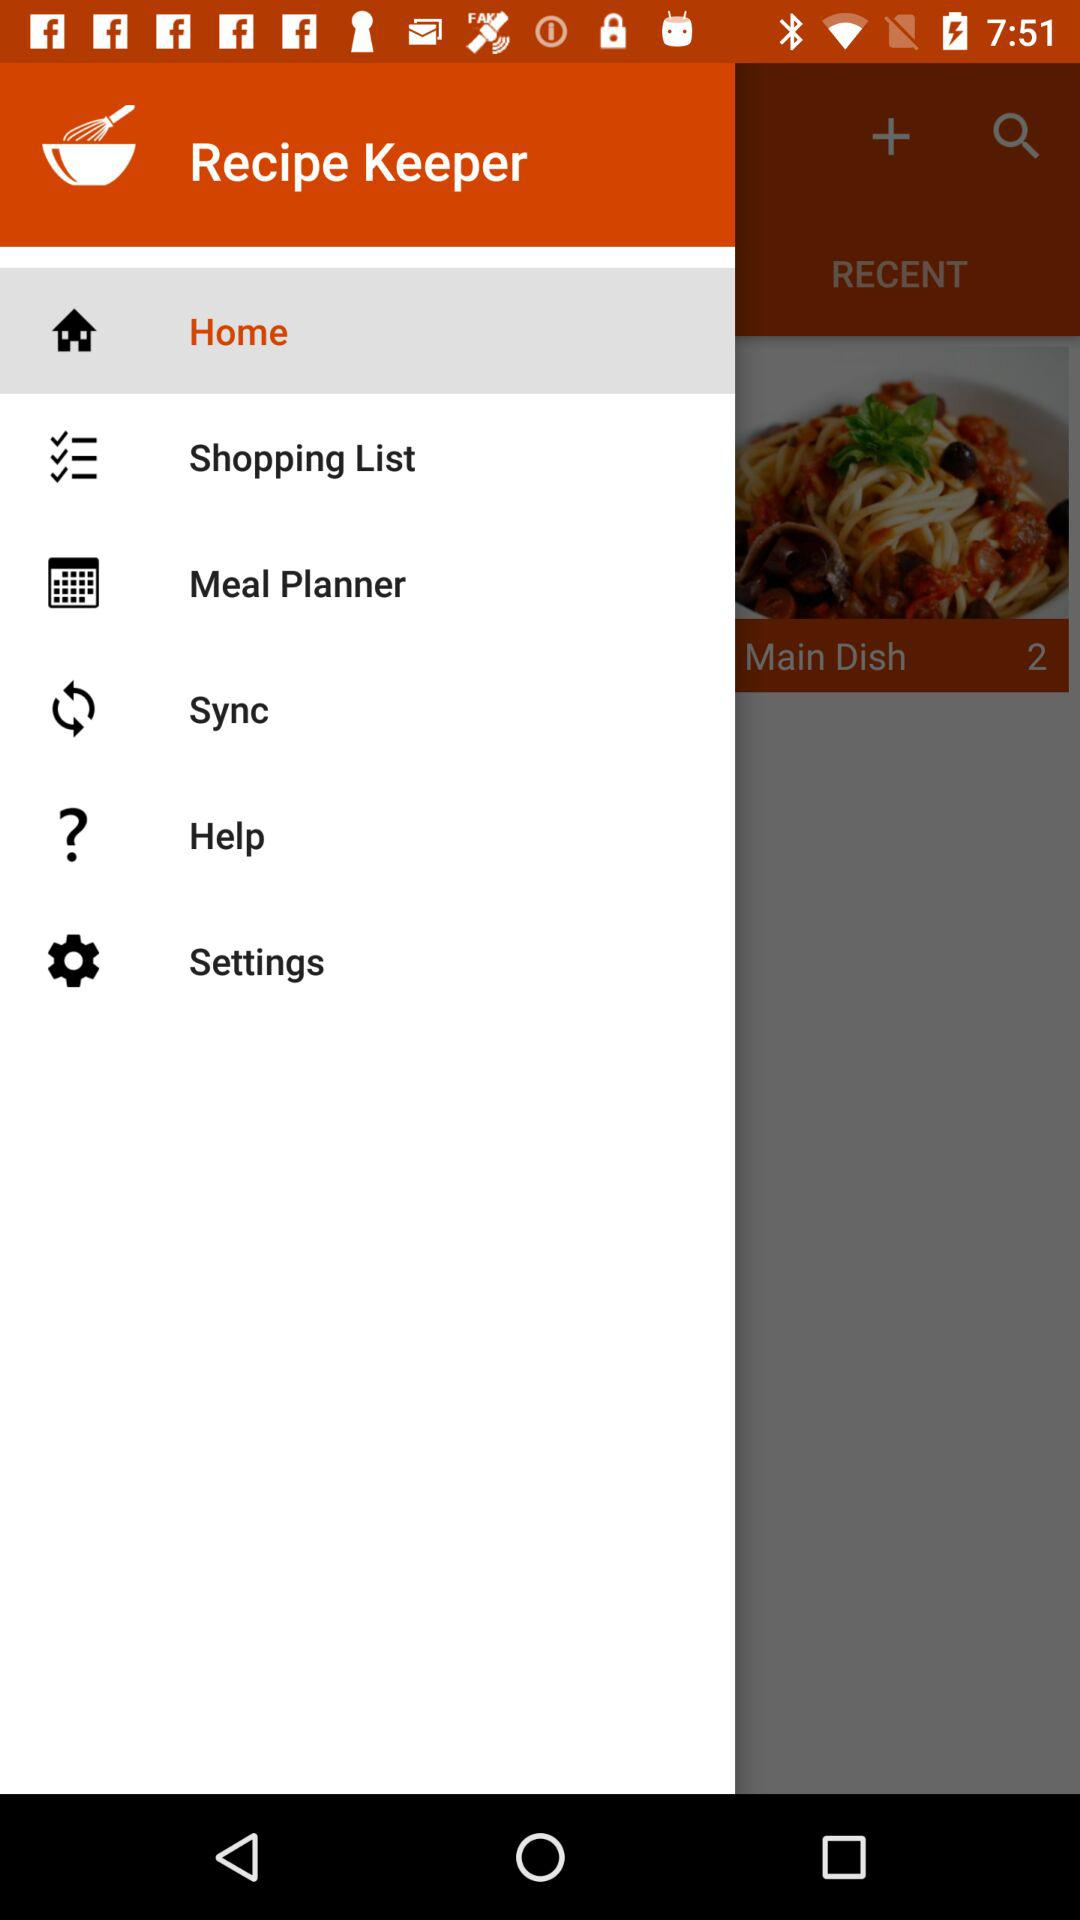Which option is selected? The selected option is "Home". 